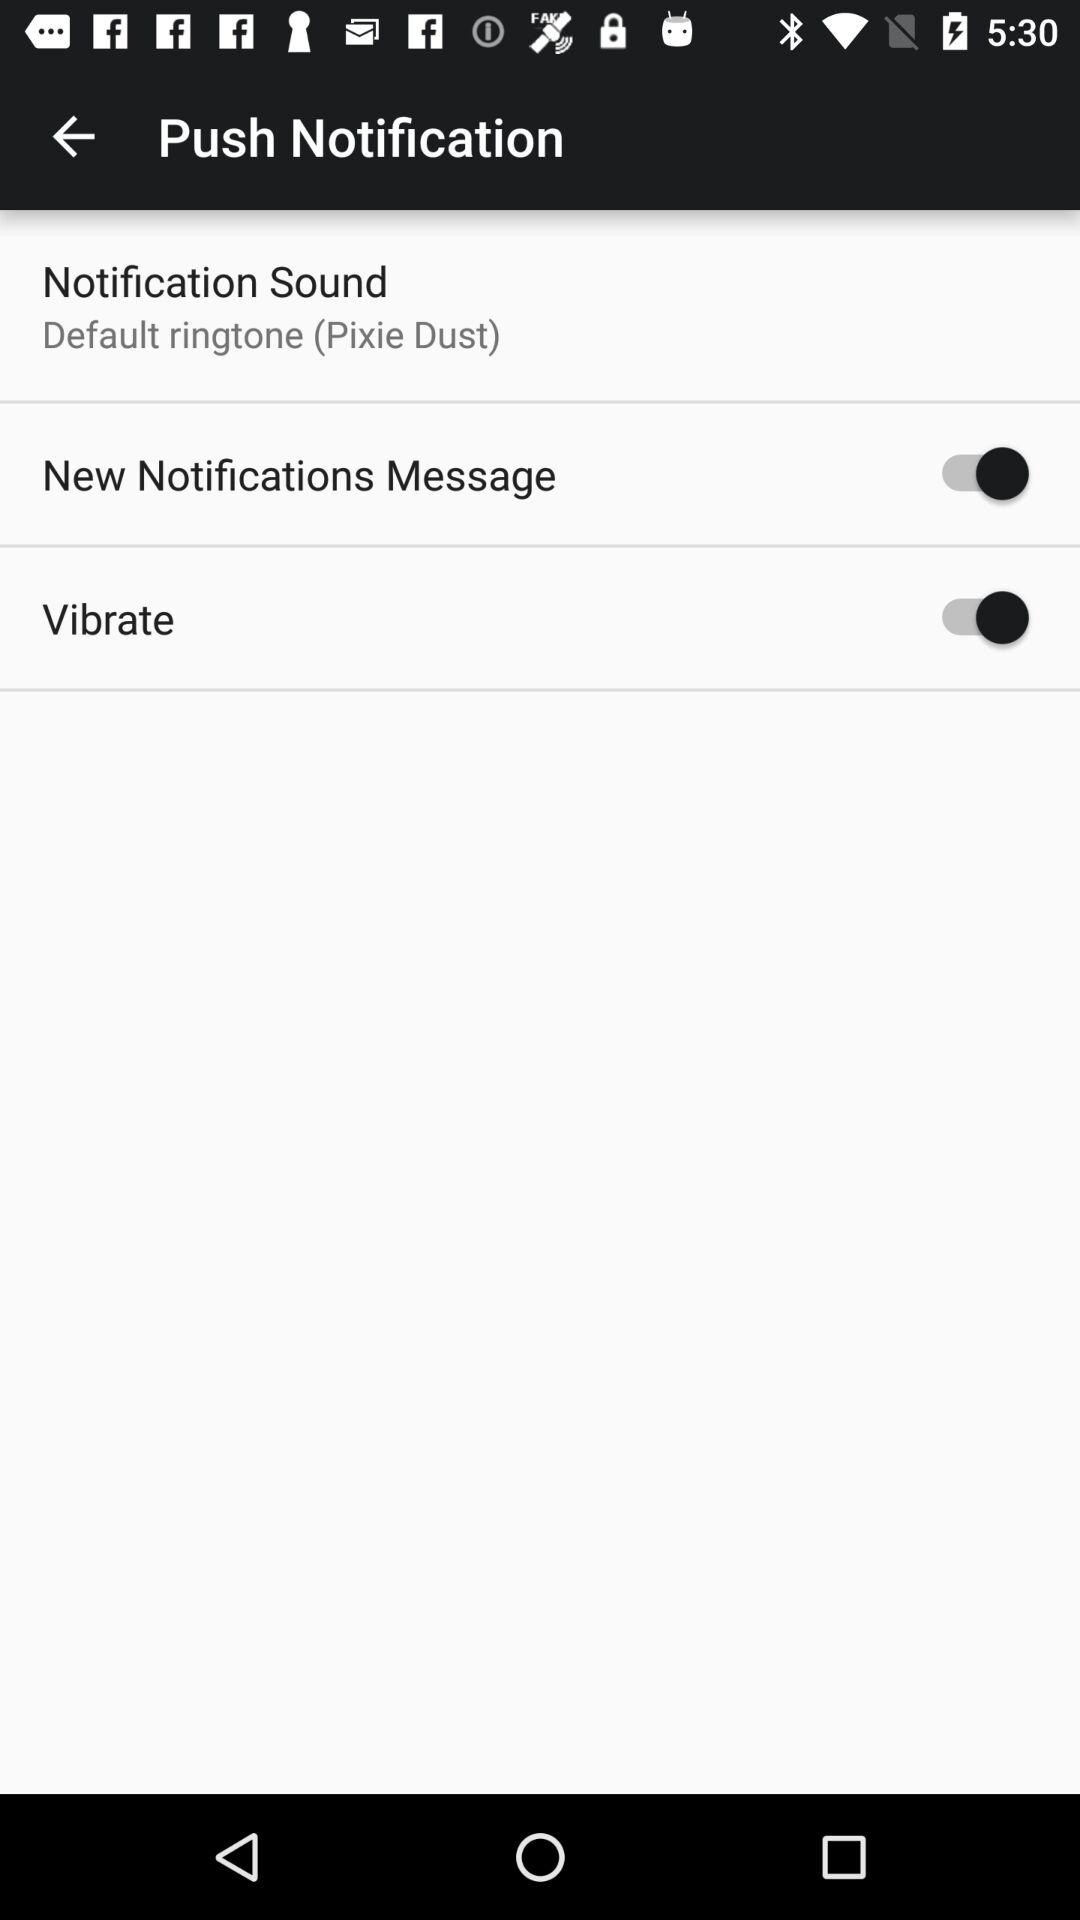What is the notification sound? The notification sound is "Default ringtone (Pixie Dust)". 